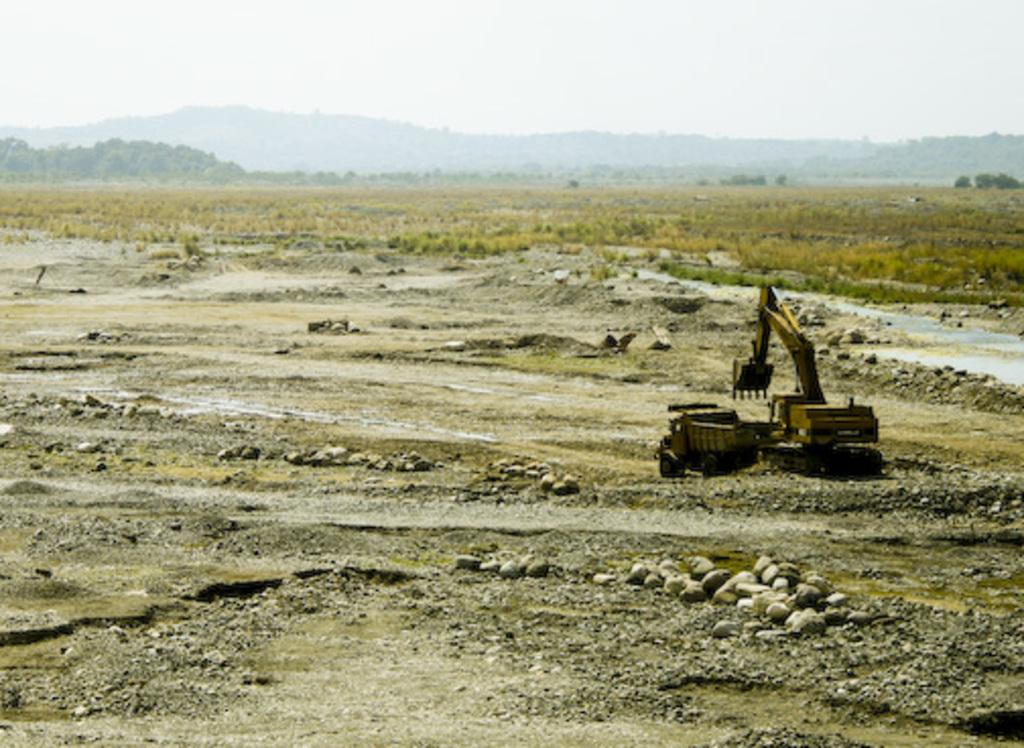What type of vehicle is on the surface in the image? The type of vehicle cannot be determined from the image. What else can be seen on the surface besides the vehicle? There are stones visible in the image. What type of vegetation is in the background of the image? There is grass in the background of the image. What else can be seen in the background besides the grass? There are trees and the sky visible in the background of the image. What type of insurance does the vehicle in the image have? There is no information about the vehicle's insurance in the image. What caused the vehicle to be in its current position in the image? The cause of the vehicle's position cannot be determined from the image. 